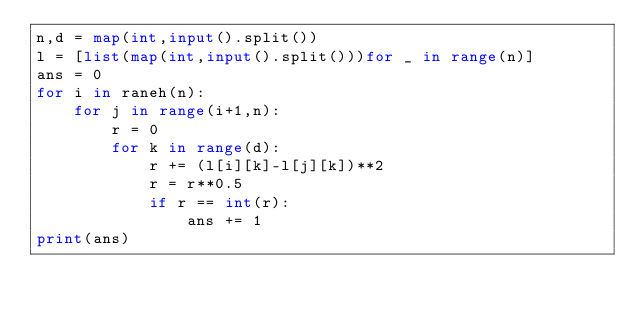Convert code to text. <code><loc_0><loc_0><loc_500><loc_500><_Python_>n,d = map(int,input().split())
l = [list(map(int,input().split()))for _ in range(n)]
ans = 0
for i in raneh(n):
    for j in range(i+1,n):
        r = 0
        for k in range(d):
            r += (l[i][k]-l[j][k])**2
            r = r**0.5
            if r == int(r):
                ans += 1
print(ans)</code> 